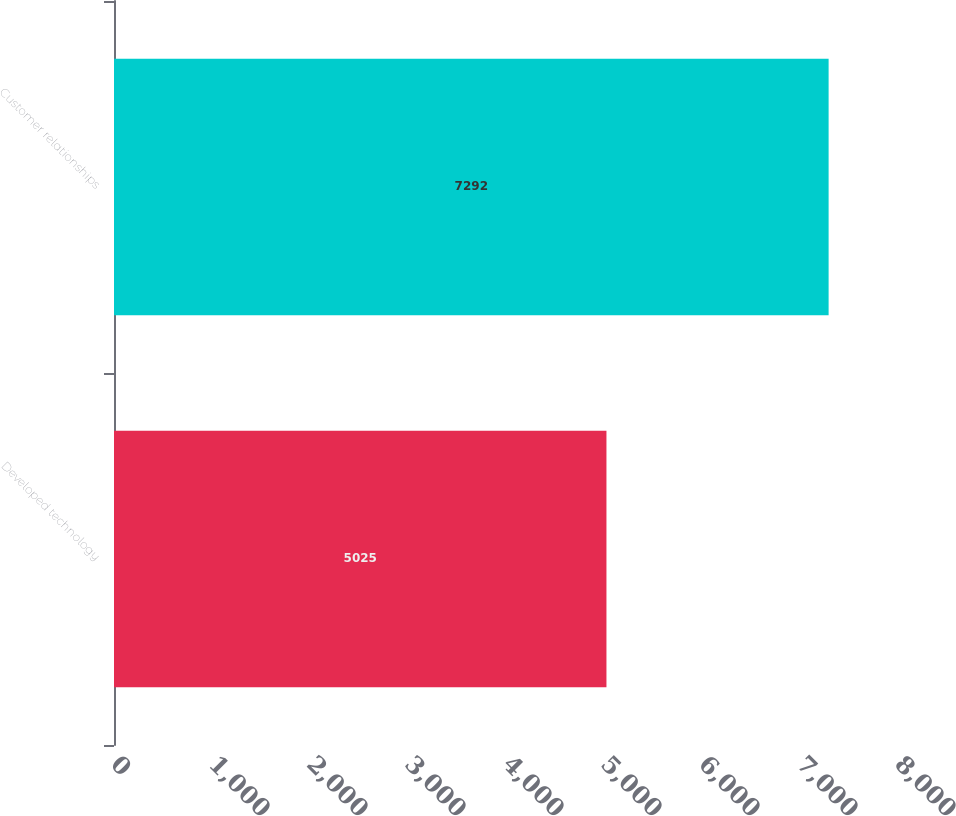Convert chart to OTSL. <chart><loc_0><loc_0><loc_500><loc_500><bar_chart><fcel>Developed technology<fcel>Customer relationships<nl><fcel>5025<fcel>7292<nl></chart> 